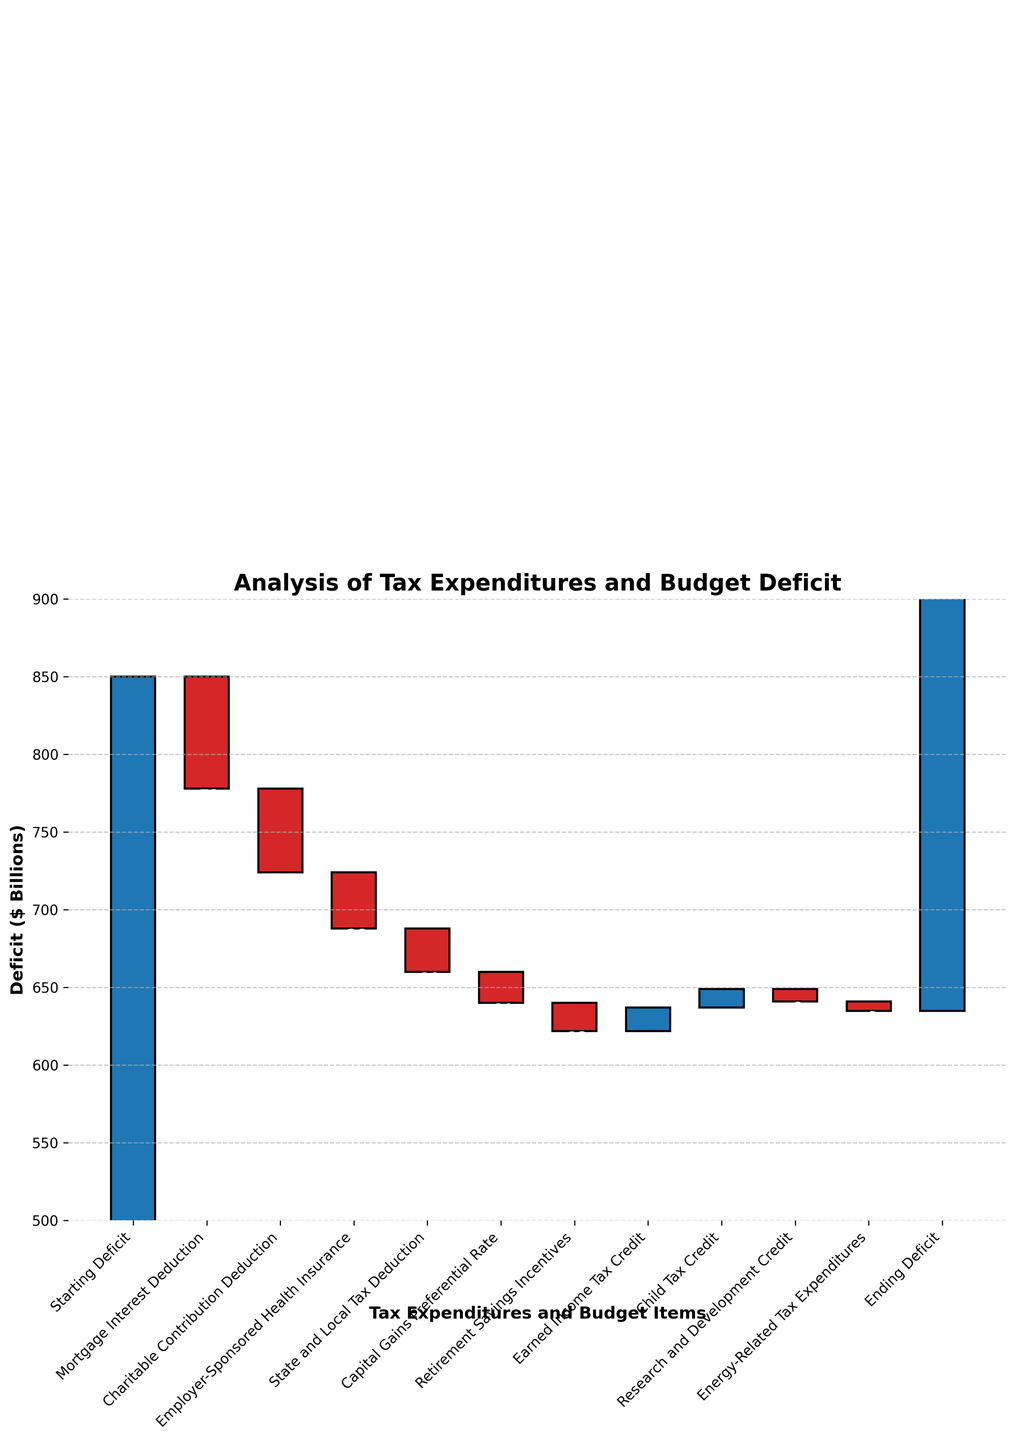What is the title of the chart? The title is usually found at the top of the chart. In this case, the title is "Analysis of Tax Expenditures and Budget Deficit."
Answer: Analysis of Tax Expenditures and Budget Deficit What is the starting deficit amount? The starting deficit amount is represented by the first bar in the chart labeled "Starting Deficit," which has a value of 850.
Answer: 850 How much does the Mortgage Interest Deduction reduce the deficit? The value associated with the Mortgage Interest Deduction is seen directly on the bar labeled "Mortgage Interest Deduction," which shows a reduction of 72.
Answer: 72 By how much does the Charitable Contribution Deduction lower the deficit compared to the Employer-Sponsored Health Insurance? To compare, first find the value of the Charitable Contribution Deduction (-54) and Employer-Sponsored Health Insurance (-36), then calculate the difference: -54 - (-36) = -18. So, it lowers the deficit by 18 more.
Answer: 18 What is the ending deficit amount after all tax expenditures are considered? The ending deficit amount is denoted by the last bar labeled "Ending Deficit," which shows a value of 635.
Answer: 635 Which tax expenditure has the smallest impact on the deficit? To determine this, look for the bar with the smallest negative value. The Energy-Related Tax Expenditures have the smallest impact with a value of -6.
Answer: Energy-Related Tax Expenditures How does the contribution of the Child Tax Credit to the deficit differ from the Earned Income Tax Credit? The Child Tax Credit increases the deficit by 12, while the Earned Income Tax Credit increases the deficit by 15. The difference is 15 - 12 = 3. So, the Child Tax Credit contributes 3 less.
Answer: 3 What is the net impact of the State and Local Tax Deduction and Capital Gains Preferential Rate on the deficit? The net impact is the sum of the values of the State and Local Tax Deduction (-28) and Capital Gains Preferential Rate (-20), which is -28 + (-20) = -48.
Answer: -48 What is the cumulative deficit amount right after the Charitable Contribution Deduction is applied? To find this, start from the Starting Deficit (850) and subtract the Mortgage Interest Deduction (850 - 72 = 778). Then subtract the Charitable Contribution Deduction (778 - 54 = 724).
Answer: 724 Which tax expenditure contributes more to the deficit reduction, Employer-Sponsored Health Insurance or Research and Development Credit? Compare the values of Employer-Sponsored Health Insurance (-36) and Research and Development Credit (-8). Since -36 is less than -8, Employer-Sponsored Health Insurance contributes more.
Answer: Employer-Sponsored Health Insurance 